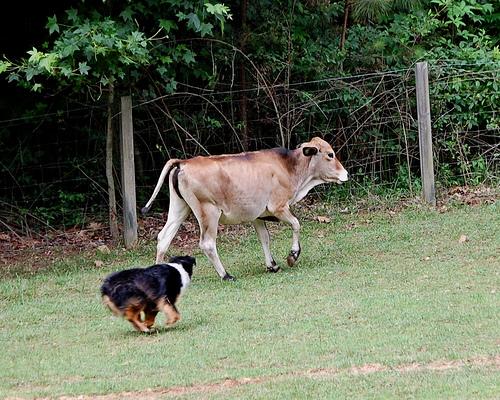Is the cow chasing the dog?
Quick response, please. No. Is there a fence in the picture?
Quick response, please. Yes. Is it morning time in this picture?
Give a very brief answer. Yes. Is the dog in motion?
Keep it brief. Yes. 